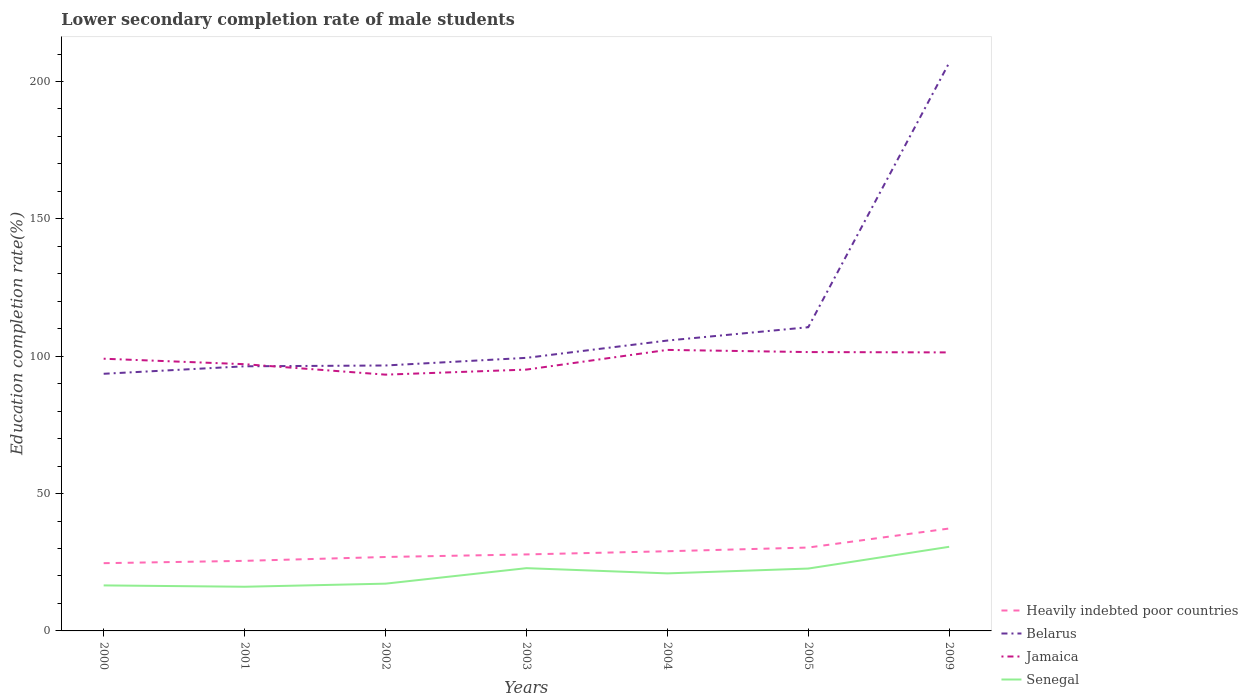How many different coloured lines are there?
Your response must be concise. 4. Does the line corresponding to Senegal intersect with the line corresponding to Belarus?
Make the answer very short. No. Across all years, what is the maximum lower secondary completion rate of male students in Jamaica?
Keep it short and to the point. 93.29. What is the total lower secondary completion rate of male students in Senegal in the graph?
Ensure brevity in your answer.  -3.74. What is the difference between the highest and the second highest lower secondary completion rate of male students in Jamaica?
Make the answer very short. 9.01. What is the difference between the highest and the lowest lower secondary completion rate of male students in Jamaica?
Offer a very short reply. 4. How many lines are there?
Your response must be concise. 4. Are the values on the major ticks of Y-axis written in scientific E-notation?
Provide a short and direct response. No. Does the graph contain any zero values?
Offer a very short reply. No. Does the graph contain grids?
Your answer should be very brief. No. How many legend labels are there?
Offer a terse response. 4. How are the legend labels stacked?
Provide a short and direct response. Vertical. What is the title of the graph?
Your response must be concise. Lower secondary completion rate of male students. Does "Ethiopia" appear as one of the legend labels in the graph?
Your answer should be very brief. No. What is the label or title of the Y-axis?
Your response must be concise. Education completion rate(%). What is the Education completion rate(%) in Heavily indebted poor countries in 2000?
Offer a terse response. 24.66. What is the Education completion rate(%) of Belarus in 2000?
Your response must be concise. 93.61. What is the Education completion rate(%) of Jamaica in 2000?
Give a very brief answer. 99.09. What is the Education completion rate(%) in Senegal in 2000?
Keep it short and to the point. 16.57. What is the Education completion rate(%) in Heavily indebted poor countries in 2001?
Offer a very short reply. 25.51. What is the Education completion rate(%) in Belarus in 2001?
Your answer should be compact. 96.33. What is the Education completion rate(%) of Jamaica in 2001?
Keep it short and to the point. 97.1. What is the Education completion rate(%) of Senegal in 2001?
Provide a short and direct response. 16.08. What is the Education completion rate(%) in Heavily indebted poor countries in 2002?
Your response must be concise. 26.91. What is the Education completion rate(%) in Belarus in 2002?
Provide a succinct answer. 96.63. What is the Education completion rate(%) in Jamaica in 2002?
Offer a terse response. 93.29. What is the Education completion rate(%) in Senegal in 2002?
Your answer should be very brief. 17.2. What is the Education completion rate(%) of Heavily indebted poor countries in 2003?
Provide a short and direct response. 27.85. What is the Education completion rate(%) of Belarus in 2003?
Provide a short and direct response. 99.41. What is the Education completion rate(%) of Jamaica in 2003?
Provide a short and direct response. 95.13. What is the Education completion rate(%) in Senegal in 2003?
Offer a terse response. 22.85. What is the Education completion rate(%) in Heavily indebted poor countries in 2004?
Ensure brevity in your answer.  29. What is the Education completion rate(%) in Belarus in 2004?
Give a very brief answer. 105.7. What is the Education completion rate(%) of Jamaica in 2004?
Ensure brevity in your answer.  102.3. What is the Education completion rate(%) in Senegal in 2004?
Your answer should be compact. 20.95. What is the Education completion rate(%) of Heavily indebted poor countries in 2005?
Offer a very short reply. 30.36. What is the Education completion rate(%) in Belarus in 2005?
Offer a terse response. 110.55. What is the Education completion rate(%) in Jamaica in 2005?
Offer a terse response. 101.51. What is the Education completion rate(%) in Senegal in 2005?
Ensure brevity in your answer.  22.7. What is the Education completion rate(%) in Heavily indebted poor countries in 2009?
Keep it short and to the point. 37.29. What is the Education completion rate(%) in Belarus in 2009?
Ensure brevity in your answer.  206.82. What is the Education completion rate(%) of Jamaica in 2009?
Your response must be concise. 101.39. What is the Education completion rate(%) of Senegal in 2009?
Your answer should be very brief. 30.62. Across all years, what is the maximum Education completion rate(%) of Heavily indebted poor countries?
Your response must be concise. 37.29. Across all years, what is the maximum Education completion rate(%) of Belarus?
Keep it short and to the point. 206.82. Across all years, what is the maximum Education completion rate(%) in Jamaica?
Your answer should be very brief. 102.3. Across all years, what is the maximum Education completion rate(%) in Senegal?
Ensure brevity in your answer.  30.62. Across all years, what is the minimum Education completion rate(%) of Heavily indebted poor countries?
Offer a terse response. 24.66. Across all years, what is the minimum Education completion rate(%) of Belarus?
Your answer should be very brief. 93.61. Across all years, what is the minimum Education completion rate(%) of Jamaica?
Your response must be concise. 93.29. Across all years, what is the minimum Education completion rate(%) in Senegal?
Your response must be concise. 16.08. What is the total Education completion rate(%) of Heavily indebted poor countries in the graph?
Offer a very short reply. 201.58. What is the total Education completion rate(%) of Belarus in the graph?
Offer a terse response. 809.05. What is the total Education completion rate(%) in Jamaica in the graph?
Your answer should be compact. 689.82. What is the total Education completion rate(%) in Senegal in the graph?
Your response must be concise. 146.97. What is the difference between the Education completion rate(%) of Heavily indebted poor countries in 2000 and that in 2001?
Offer a very short reply. -0.85. What is the difference between the Education completion rate(%) in Belarus in 2000 and that in 2001?
Offer a very short reply. -2.72. What is the difference between the Education completion rate(%) in Jamaica in 2000 and that in 2001?
Your answer should be very brief. 1.99. What is the difference between the Education completion rate(%) of Senegal in 2000 and that in 2001?
Give a very brief answer. 0.49. What is the difference between the Education completion rate(%) in Heavily indebted poor countries in 2000 and that in 2002?
Ensure brevity in your answer.  -2.25. What is the difference between the Education completion rate(%) in Belarus in 2000 and that in 2002?
Your response must be concise. -3.02. What is the difference between the Education completion rate(%) in Jamaica in 2000 and that in 2002?
Your response must be concise. 5.8. What is the difference between the Education completion rate(%) of Senegal in 2000 and that in 2002?
Make the answer very short. -0.64. What is the difference between the Education completion rate(%) of Heavily indebted poor countries in 2000 and that in 2003?
Give a very brief answer. -3.19. What is the difference between the Education completion rate(%) in Belarus in 2000 and that in 2003?
Make the answer very short. -5.8. What is the difference between the Education completion rate(%) in Jamaica in 2000 and that in 2003?
Your response must be concise. 3.96. What is the difference between the Education completion rate(%) of Senegal in 2000 and that in 2003?
Make the answer very short. -6.28. What is the difference between the Education completion rate(%) in Heavily indebted poor countries in 2000 and that in 2004?
Make the answer very short. -4.34. What is the difference between the Education completion rate(%) of Belarus in 2000 and that in 2004?
Your answer should be compact. -12.1. What is the difference between the Education completion rate(%) in Jamaica in 2000 and that in 2004?
Ensure brevity in your answer.  -3.21. What is the difference between the Education completion rate(%) in Senegal in 2000 and that in 2004?
Your answer should be very brief. -4.38. What is the difference between the Education completion rate(%) in Heavily indebted poor countries in 2000 and that in 2005?
Offer a very short reply. -5.7. What is the difference between the Education completion rate(%) in Belarus in 2000 and that in 2005?
Give a very brief answer. -16.95. What is the difference between the Education completion rate(%) in Jamaica in 2000 and that in 2005?
Make the answer very short. -2.42. What is the difference between the Education completion rate(%) in Senegal in 2000 and that in 2005?
Offer a very short reply. -6.14. What is the difference between the Education completion rate(%) in Heavily indebted poor countries in 2000 and that in 2009?
Make the answer very short. -12.62. What is the difference between the Education completion rate(%) of Belarus in 2000 and that in 2009?
Your answer should be compact. -113.22. What is the difference between the Education completion rate(%) of Jamaica in 2000 and that in 2009?
Ensure brevity in your answer.  -2.3. What is the difference between the Education completion rate(%) of Senegal in 2000 and that in 2009?
Your response must be concise. -14.06. What is the difference between the Education completion rate(%) of Heavily indebted poor countries in 2001 and that in 2002?
Offer a terse response. -1.4. What is the difference between the Education completion rate(%) in Belarus in 2001 and that in 2002?
Ensure brevity in your answer.  -0.3. What is the difference between the Education completion rate(%) in Jamaica in 2001 and that in 2002?
Your answer should be compact. 3.81. What is the difference between the Education completion rate(%) of Senegal in 2001 and that in 2002?
Provide a succinct answer. -1.12. What is the difference between the Education completion rate(%) of Heavily indebted poor countries in 2001 and that in 2003?
Your response must be concise. -2.34. What is the difference between the Education completion rate(%) of Belarus in 2001 and that in 2003?
Your answer should be very brief. -3.08. What is the difference between the Education completion rate(%) in Jamaica in 2001 and that in 2003?
Provide a succinct answer. 1.97. What is the difference between the Education completion rate(%) in Senegal in 2001 and that in 2003?
Make the answer very short. -6.77. What is the difference between the Education completion rate(%) of Heavily indebted poor countries in 2001 and that in 2004?
Provide a short and direct response. -3.49. What is the difference between the Education completion rate(%) of Belarus in 2001 and that in 2004?
Offer a very short reply. -9.37. What is the difference between the Education completion rate(%) of Jamaica in 2001 and that in 2004?
Your response must be concise. -5.2. What is the difference between the Education completion rate(%) in Senegal in 2001 and that in 2004?
Provide a succinct answer. -4.87. What is the difference between the Education completion rate(%) of Heavily indebted poor countries in 2001 and that in 2005?
Offer a terse response. -4.85. What is the difference between the Education completion rate(%) in Belarus in 2001 and that in 2005?
Provide a short and direct response. -14.22. What is the difference between the Education completion rate(%) of Jamaica in 2001 and that in 2005?
Offer a very short reply. -4.41. What is the difference between the Education completion rate(%) of Senegal in 2001 and that in 2005?
Your answer should be very brief. -6.62. What is the difference between the Education completion rate(%) in Heavily indebted poor countries in 2001 and that in 2009?
Give a very brief answer. -11.78. What is the difference between the Education completion rate(%) of Belarus in 2001 and that in 2009?
Offer a terse response. -110.49. What is the difference between the Education completion rate(%) of Jamaica in 2001 and that in 2009?
Keep it short and to the point. -4.29. What is the difference between the Education completion rate(%) of Senegal in 2001 and that in 2009?
Offer a very short reply. -14.54. What is the difference between the Education completion rate(%) of Heavily indebted poor countries in 2002 and that in 2003?
Keep it short and to the point. -0.94. What is the difference between the Education completion rate(%) in Belarus in 2002 and that in 2003?
Your answer should be compact. -2.78. What is the difference between the Education completion rate(%) in Jamaica in 2002 and that in 2003?
Keep it short and to the point. -1.84. What is the difference between the Education completion rate(%) of Senegal in 2002 and that in 2003?
Your response must be concise. -5.64. What is the difference between the Education completion rate(%) in Heavily indebted poor countries in 2002 and that in 2004?
Give a very brief answer. -2.09. What is the difference between the Education completion rate(%) of Belarus in 2002 and that in 2004?
Offer a terse response. -9.08. What is the difference between the Education completion rate(%) of Jamaica in 2002 and that in 2004?
Ensure brevity in your answer.  -9.01. What is the difference between the Education completion rate(%) of Senegal in 2002 and that in 2004?
Keep it short and to the point. -3.74. What is the difference between the Education completion rate(%) in Heavily indebted poor countries in 2002 and that in 2005?
Your response must be concise. -3.44. What is the difference between the Education completion rate(%) of Belarus in 2002 and that in 2005?
Provide a short and direct response. -13.93. What is the difference between the Education completion rate(%) in Jamaica in 2002 and that in 2005?
Your response must be concise. -8.22. What is the difference between the Education completion rate(%) in Senegal in 2002 and that in 2005?
Give a very brief answer. -5.5. What is the difference between the Education completion rate(%) of Heavily indebted poor countries in 2002 and that in 2009?
Your answer should be compact. -10.37. What is the difference between the Education completion rate(%) of Belarus in 2002 and that in 2009?
Your answer should be compact. -110.2. What is the difference between the Education completion rate(%) of Jamaica in 2002 and that in 2009?
Keep it short and to the point. -8.09. What is the difference between the Education completion rate(%) of Senegal in 2002 and that in 2009?
Make the answer very short. -13.42. What is the difference between the Education completion rate(%) of Heavily indebted poor countries in 2003 and that in 2004?
Your response must be concise. -1.16. What is the difference between the Education completion rate(%) of Belarus in 2003 and that in 2004?
Make the answer very short. -6.3. What is the difference between the Education completion rate(%) of Jamaica in 2003 and that in 2004?
Keep it short and to the point. -7.17. What is the difference between the Education completion rate(%) in Senegal in 2003 and that in 2004?
Provide a succinct answer. 1.9. What is the difference between the Education completion rate(%) of Heavily indebted poor countries in 2003 and that in 2005?
Give a very brief answer. -2.51. What is the difference between the Education completion rate(%) of Belarus in 2003 and that in 2005?
Offer a terse response. -11.14. What is the difference between the Education completion rate(%) of Jamaica in 2003 and that in 2005?
Ensure brevity in your answer.  -6.38. What is the difference between the Education completion rate(%) of Senegal in 2003 and that in 2005?
Your answer should be compact. 0.14. What is the difference between the Education completion rate(%) of Heavily indebted poor countries in 2003 and that in 2009?
Offer a very short reply. -9.44. What is the difference between the Education completion rate(%) in Belarus in 2003 and that in 2009?
Offer a very short reply. -107.42. What is the difference between the Education completion rate(%) of Jamaica in 2003 and that in 2009?
Provide a succinct answer. -6.26. What is the difference between the Education completion rate(%) in Senegal in 2003 and that in 2009?
Your response must be concise. -7.78. What is the difference between the Education completion rate(%) in Heavily indebted poor countries in 2004 and that in 2005?
Provide a succinct answer. -1.35. What is the difference between the Education completion rate(%) in Belarus in 2004 and that in 2005?
Provide a succinct answer. -4.85. What is the difference between the Education completion rate(%) of Jamaica in 2004 and that in 2005?
Make the answer very short. 0.79. What is the difference between the Education completion rate(%) of Senegal in 2004 and that in 2005?
Offer a terse response. -1.76. What is the difference between the Education completion rate(%) in Heavily indebted poor countries in 2004 and that in 2009?
Provide a succinct answer. -8.28. What is the difference between the Education completion rate(%) of Belarus in 2004 and that in 2009?
Your answer should be compact. -101.12. What is the difference between the Education completion rate(%) in Jamaica in 2004 and that in 2009?
Give a very brief answer. 0.91. What is the difference between the Education completion rate(%) in Senegal in 2004 and that in 2009?
Offer a very short reply. -9.68. What is the difference between the Education completion rate(%) in Heavily indebted poor countries in 2005 and that in 2009?
Your response must be concise. -6.93. What is the difference between the Education completion rate(%) in Belarus in 2005 and that in 2009?
Provide a succinct answer. -96.27. What is the difference between the Education completion rate(%) of Jamaica in 2005 and that in 2009?
Make the answer very short. 0.12. What is the difference between the Education completion rate(%) of Senegal in 2005 and that in 2009?
Provide a succinct answer. -7.92. What is the difference between the Education completion rate(%) in Heavily indebted poor countries in 2000 and the Education completion rate(%) in Belarus in 2001?
Provide a short and direct response. -71.67. What is the difference between the Education completion rate(%) in Heavily indebted poor countries in 2000 and the Education completion rate(%) in Jamaica in 2001?
Offer a very short reply. -72.44. What is the difference between the Education completion rate(%) in Heavily indebted poor countries in 2000 and the Education completion rate(%) in Senegal in 2001?
Keep it short and to the point. 8.58. What is the difference between the Education completion rate(%) in Belarus in 2000 and the Education completion rate(%) in Jamaica in 2001?
Your answer should be compact. -3.49. What is the difference between the Education completion rate(%) of Belarus in 2000 and the Education completion rate(%) of Senegal in 2001?
Offer a terse response. 77.53. What is the difference between the Education completion rate(%) in Jamaica in 2000 and the Education completion rate(%) in Senegal in 2001?
Provide a succinct answer. 83.01. What is the difference between the Education completion rate(%) in Heavily indebted poor countries in 2000 and the Education completion rate(%) in Belarus in 2002?
Offer a very short reply. -71.97. What is the difference between the Education completion rate(%) of Heavily indebted poor countries in 2000 and the Education completion rate(%) of Jamaica in 2002?
Give a very brief answer. -68.63. What is the difference between the Education completion rate(%) in Heavily indebted poor countries in 2000 and the Education completion rate(%) in Senegal in 2002?
Ensure brevity in your answer.  7.46. What is the difference between the Education completion rate(%) of Belarus in 2000 and the Education completion rate(%) of Jamaica in 2002?
Your response must be concise. 0.31. What is the difference between the Education completion rate(%) in Belarus in 2000 and the Education completion rate(%) in Senegal in 2002?
Provide a short and direct response. 76.4. What is the difference between the Education completion rate(%) of Jamaica in 2000 and the Education completion rate(%) of Senegal in 2002?
Keep it short and to the point. 81.89. What is the difference between the Education completion rate(%) in Heavily indebted poor countries in 2000 and the Education completion rate(%) in Belarus in 2003?
Offer a very short reply. -74.75. What is the difference between the Education completion rate(%) of Heavily indebted poor countries in 2000 and the Education completion rate(%) of Jamaica in 2003?
Offer a very short reply. -70.47. What is the difference between the Education completion rate(%) in Heavily indebted poor countries in 2000 and the Education completion rate(%) in Senegal in 2003?
Make the answer very short. 1.81. What is the difference between the Education completion rate(%) in Belarus in 2000 and the Education completion rate(%) in Jamaica in 2003?
Your response must be concise. -1.53. What is the difference between the Education completion rate(%) in Belarus in 2000 and the Education completion rate(%) in Senegal in 2003?
Your response must be concise. 70.76. What is the difference between the Education completion rate(%) in Jamaica in 2000 and the Education completion rate(%) in Senegal in 2003?
Offer a terse response. 76.24. What is the difference between the Education completion rate(%) of Heavily indebted poor countries in 2000 and the Education completion rate(%) of Belarus in 2004?
Make the answer very short. -81.04. What is the difference between the Education completion rate(%) in Heavily indebted poor countries in 2000 and the Education completion rate(%) in Jamaica in 2004?
Provide a short and direct response. -77.64. What is the difference between the Education completion rate(%) of Heavily indebted poor countries in 2000 and the Education completion rate(%) of Senegal in 2004?
Keep it short and to the point. 3.71. What is the difference between the Education completion rate(%) in Belarus in 2000 and the Education completion rate(%) in Jamaica in 2004?
Provide a short and direct response. -8.69. What is the difference between the Education completion rate(%) of Belarus in 2000 and the Education completion rate(%) of Senegal in 2004?
Keep it short and to the point. 72.66. What is the difference between the Education completion rate(%) in Jamaica in 2000 and the Education completion rate(%) in Senegal in 2004?
Your answer should be very brief. 78.14. What is the difference between the Education completion rate(%) in Heavily indebted poor countries in 2000 and the Education completion rate(%) in Belarus in 2005?
Give a very brief answer. -85.89. What is the difference between the Education completion rate(%) in Heavily indebted poor countries in 2000 and the Education completion rate(%) in Jamaica in 2005?
Make the answer very short. -76.85. What is the difference between the Education completion rate(%) of Heavily indebted poor countries in 2000 and the Education completion rate(%) of Senegal in 2005?
Your answer should be compact. 1.96. What is the difference between the Education completion rate(%) in Belarus in 2000 and the Education completion rate(%) in Jamaica in 2005?
Provide a short and direct response. -7.9. What is the difference between the Education completion rate(%) of Belarus in 2000 and the Education completion rate(%) of Senegal in 2005?
Your response must be concise. 70.9. What is the difference between the Education completion rate(%) of Jamaica in 2000 and the Education completion rate(%) of Senegal in 2005?
Offer a very short reply. 76.39. What is the difference between the Education completion rate(%) in Heavily indebted poor countries in 2000 and the Education completion rate(%) in Belarus in 2009?
Offer a very short reply. -182.16. What is the difference between the Education completion rate(%) in Heavily indebted poor countries in 2000 and the Education completion rate(%) in Jamaica in 2009?
Keep it short and to the point. -76.73. What is the difference between the Education completion rate(%) in Heavily indebted poor countries in 2000 and the Education completion rate(%) in Senegal in 2009?
Give a very brief answer. -5.96. What is the difference between the Education completion rate(%) in Belarus in 2000 and the Education completion rate(%) in Jamaica in 2009?
Provide a succinct answer. -7.78. What is the difference between the Education completion rate(%) in Belarus in 2000 and the Education completion rate(%) in Senegal in 2009?
Provide a short and direct response. 62.98. What is the difference between the Education completion rate(%) in Jamaica in 2000 and the Education completion rate(%) in Senegal in 2009?
Ensure brevity in your answer.  68.47. What is the difference between the Education completion rate(%) in Heavily indebted poor countries in 2001 and the Education completion rate(%) in Belarus in 2002?
Offer a terse response. -71.12. What is the difference between the Education completion rate(%) of Heavily indebted poor countries in 2001 and the Education completion rate(%) of Jamaica in 2002?
Provide a short and direct response. -67.78. What is the difference between the Education completion rate(%) of Heavily indebted poor countries in 2001 and the Education completion rate(%) of Senegal in 2002?
Your answer should be very brief. 8.31. What is the difference between the Education completion rate(%) in Belarus in 2001 and the Education completion rate(%) in Jamaica in 2002?
Offer a terse response. 3.04. What is the difference between the Education completion rate(%) of Belarus in 2001 and the Education completion rate(%) of Senegal in 2002?
Make the answer very short. 79.13. What is the difference between the Education completion rate(%) of Jamaica in 2001 and the Education completion rate(%) of Senegal in 2002?
Provide a succinct answer. 79.9. What is the difference between the Education completion rate(%) of Heavily indebted poor countries in 2001 and the Education completion rate(%) of Belarus in 2003?
Provide a short and direct response. -73.9. What is the difference between the Education completion rate(%) of Heavily indebted poor countries in 2001 and the Education completion rate(%) of Jamaica in 2003?
Keep it short and to the point. -69.62. What is the difference between the Education completion rate(%) in Heavily indebted poor countries in 2001 and the Education completion rate(%) in Senegal in 2003?
Your answer should be compact. 2.66. What is the difference between the Education completion rate(%) of Belarus in 2001 and the Education completion rate(%) of Jamaica in 2003?
Offer a terse response. 1.2. What is the difference between the Education completion rate(%) of Belarus in 2001 and the Education completion rate(%) of Senegal in 2003?
Offer a terse response. 73.48. What is the difference between the Education completion rate(%) of Jamaica in 2001 and the Education completion rate(%) of Senegal in 2003?
Offer a terse response. 74.25. What is the difference between the Education completion rate(%) of Heavily indebted poor countries in 2001 and the Education completion rate(%) of Belarus in 2004?
Give a very brief answer. -80.19. What is the difference between the Education completion rate(%) of Heavily indebted poor countries in 2001 and the Education completion rate(%) of Jamaica in 2004?
Ensure brevity in your answer.  -76.79. What is the difference between the Education completion rate(%) of Heavily indebted poor countries in 2001 and the Education completion rate(%) of Senegal in 2004?
Give a very brief answer. 4.56. What is the difference between the Education completion rate(%) in Belarus in 2001 and the Education completion rate(%) in Jamaica in 2004?
Offer a terse response. -5.97. What is the difference between the Education completion rate(%) of Belarus in 2001 and the Education completion rate(%) of Senegal in 2004?
Give a very brief answer. 75.38. What is the difference between the Education completion rate(%) in Jamaica in 2001 and the Education completion rate(%) in Senegal in 2004?
Make the answer very short. 76.15. What is the difference between the Education completion rate(%) of Heavily indebted poor countries in 2001 and the Education completion rate(%) of Belarus in 2005?
Offer a very short reply. -85.04. What is the difference between the Education completion rate(%) of Heavily indebted poor countries in 2001 and the Education completion rate(%) of Jamaica in 2005?
Provide a succinct answer. -76. What is the difference between the Education completion rate(%) in Heavily indebted poor countries in 2001 and the Education completion rate(%) in Senegal in 2005?
Your answer should be compact. 2.81. What is the difference between the Education completion rate(%) in Belarus in 2001 and the Education completion rate(%) in Jamaica in 2005?
Your answer should be very brief. -5.18. What is the difference between the Education completion rate(%) in Belarus in 2001 and the Education completion rate(%) in Senegal in 2005?
Keep it short and to the point. 73.63. What is the difference between the Education completion rate(%) of Jamaica in 2001 and the Education completion rate(%) of Senegal in 2005?
Your answer should be compact. 74.4. What is the difference between the Education completion rate(%) in Heavily indebted poor countries in 2001 and the Education completion rate(%) in Belarus in 2009?
Provide a succinct answer. -181.31. What is the difference between the Education completion rate(%) in Heavily indebted poor countries in 2001 and the Education completion rate(%) in Jamaica in 2009?
Your answer should be compact. -75.88. What is the difference between the Education completion rate(%) of Heavily indebted poor countries in 2001 and the Education completion rate(%) of Senegal in 2009?
Give a very brief answer. -5.11. What is the difference between the Education completion rate(%) in Belarus in 2001 and the Education completion rate(%) in Jamaica in 2009?
Provide a short and direct response. -5.06. What is the difference between the Education completion rate(%) of Belarus in 2001 and the Education completion rate(%) of Senegal in 2009?
Keep it short and to the point. 65.71. What is the difference between the Education completion rate(%) of Jamaica in 2001 and the Education completion rate(%) of Senegal in 2009?
Provide a short and direct response. 66.48. What is the difference between the Education completion rate(%) of Heavily indebted poor countries in 2002 and the Education completion rate(%) of Belarus in 2003?
Make the answer very short. -72.5. What is the difference between the Education completion rate(%) in Heavily indebted poor countries in 2002 and the Education completion rate(%) in Jamaica in 2003?
Give a very brief answer. -68.22. What is the difference between the Education completion rate(%) of Heavily indebted poor countries in 2002 and the Education completion rate(%) of Senegal in 2003?
Make the answer very short. 4.07. What is the difference between the Education completion rate(%) of Belarus in 2002 and the Education completion rate(%) of Jamaica in 2003?
Make the answer very short. 1.49. What is the difference between the Education completion rate(%) of Belarus in 2002 and the Education completion rate(%) of Senegal in 2003?
Provide a succinct answer. 73.78. What is the difference between the Education completion rate(%) in Jamaica in 2002 and the Education completion rate(%) in Senegal in 2003?
Keep it short and to the point. 70.45. What is the difference between the Education completion rate(%) of Heavily indebted poor countries in 2002 and the Education completion rate(%) of Belarus in 2004?
Offer a very short reply. -78.79. What is the difference between the Education completion rate(%) in Heavily indebted poor countries in 2002 and the Education completion rate(%) in Jamaica in 2004?
Provide a short and direct response. -75.39. What is the difference between the Education completion rate(%) in Heavily indebted poor countries in 2002 and the Education completion rate(%) in Senegal in 2004?
Your answer should be very brief. 5.97. What is the difference between the Education completion rate(%) in Belarus in 2002 and the Education completion rate(%) in Jamaica in 2004?
Provide a short and direct response. -5.67. What is the difference between the Education completion rate(%) of Belarus in 2002 and the Education completion rate(%) of Senegal in 2004?
Your answer should be compact. 75.68. What is the difference between the Education completion rate(%) of Jamaica in 2002 and the Education completion rate(%) of Senegal in 2004?
Give a very brief answer. 72.35. What is the difference between the Education completion rate(%) of Heavily indebted poor countries in 2002 and the Education completion rate(%) of Belarus in 2005?
Provide a short and direct response. -83.64. What is the difference between the Education completion rate(%) in Heavily indebted poor countries in 2002 and the Education completion rate(%) in Jamaica in 2005?
Provide a short and direct response. -74.6. What is the difference between the Education completion rate(%) of Heavily indebted poor countries in 2002 and the Education completion rate(%) of Senegal in 2005?
Offer a very short reply. 4.21. What is the difference between the Education completion rate(%) in Belarus in 2002 and the Education completion rate(%) in Jamaica in 2005?
Your response must be concise. -4.88. What is the difference between the Education completion rate(%) of Belarus in 2002 and the Education completion rate(%) of Senegal in 2005?
Offer a very short reply. 73.92. What is the difference between the Education completion rate(%) of Jamaica in 2002 and the Education completion rate(%) of Senegal in 2005?
Provide a succinct answer. 70.59. What is the difference between the Education completion rate(%) of Heavily indebted poor countries in 2002 and the Education completion rate(%) of Belarus in 2009?
Ensure brevity in your answer.  -179.91. What is the difference between the Education completion rate(%) of Heavily indebted poor countries in 2002 and the Education completion rate(%) of Jamaica in 2009?
Keep it short and to the point. -74.48. What is the difference between the Education completion rate(%) of Heavily indebted poor countries in 2002 and the Education completion rate(%) of Senegal in 2009?
Offer a very short reply. -3.71. What is the difference between the Education completion rate(%) of Belarus in 2002 and the Education completion rate(%) of Jamaica in 2009?
Offer a terse response. -4.76. What is the difference between the Education completion rate(%) of Belarus in 2002 and the Education completion rate(%) of Senegal in 2009?
Provide a succinct answer. 66. What is the difference between the Education completion rate(%) of Jamaica in 2002 and the Education completion rate(%) of Senegal in 2009?
Provide a short and direct response. 62.67. What is the difference between the Education completion rate(%) of Heavily indebted poor countries in 2003 and the Education completion rate(%) of Belarus in 2004?
Keep it short and to the point. -77.86. What is the difference between the Education completion rate(%) of Heavily indebted poor countries in 2003 and the Education completion rate(%) of Jamaica in 2004?
Your response must be concise. -74.45. What is the difference between the Education completion rate(%) in Heavily indebted poor countries in 2003 and the Education completion rate(%) in Senegal in 2004?
Your response must be concise. 6.9. What is the difference between the Education completion rate(%) in Belarus in 2003 and the Education completion rate(%) in Jamaica in 2004?
Offer a very short reply. -2.89. What is the difference between the Education completion rate(%) in Belarus in 2003 and the Education completion rate(%) in Senegal in 2004?
Your answer should be compact. 78.46. What is the difference between the Education completion rate(%) in Jamaica in 2003 and the Education completion rate(%) in Senegal in 2004?
Ensure brevity in your answer.  74.19. What is the difference between the Education completion rate(%) of Heavily indebted poor countries in 2003 and the Education completion rate(%) of Belarus in 2005?
Make the answer very short. -82.71. What is the difference between the Education completion rate(%) in Heavily indebted poor countries in 2003 and the Education completion rate(%) in Jamaica in 2005?
Offer a terse response. -73.66. What is the difference between the Education completion rate(%) in Heavily indebted poor countries in 2003 and the Education completion rate(%) in Senegal in 2005?
Provide a succinct answer. 5.14. What is the difference between the Education completion rate(%) of Belarus in 2003 and the Education completion rate(%) of Jamaica in 2005?
Provide a short and direct response. -2.1. What is the difference between the Education completion rate(%) in Belarus in 2003 and the Education completion rate(%) in Senegal in 2005?
Your answer should be very brief. 76.7. What is the difference between the Education completion rate(%) of Jamaica in 2003 and the Education completion rate(%) of Senegal in 2005?
Your answer should be very brief. 72.43. What is the difference between the Education completion rate(%) in Heavily indebted poor countries in 2003 and the Education completion rate(%) in Belarus in 2009?
Your answer should be very brief. -178.98. What is the difference between the Education completion rate(%) in Heavily indebted poor countries in 2003 and the Education completion rate(%) in Jamaica in 2009?
Provide a succinct answer. -73.54. What is the difference between the Education completion rate(%) of Heavily indebted poor countries in 2003 and the Education completion rate(%) of Senegal in 2009?
Keep it short and to the point. -2.78. What is the difference between the Education completion rate(%) in Belarus in 2003 and the Education completion rate(%) in Jamaica in 2009?
Give a very brief answer. -1.98. What is the difference between the Education completion rate(%) of Belarus in 2003 and the Education completion rate(%) of Senegal in 2009?
Your response must be concise. 68.79. What is the difference between the Education completion rate(%) in Jamaica in 2003 and the Education completion rate(%) in Senegal in 2009?
Your answer should be very brief. 64.51. What is the difference between the Education completion rate(%) in Heavily indebted poor countries in 2004 and the Education completion rate(%) in Belarus in 2005?
Ensure brevity in your answer.  -81.55. What is the difference between the Education completion rate(%) of Heavily indebted poor countries in 2004 and the Education completion rate(%) of Jamaica in 2005?
Your response must be concise. -72.51. What is the difference between the Education completion rate(%) of Heavily indebted poor countries in 2004 and the Education completion rate(%) of Senegal in 2005?
Your response must be concise. 6.3. What is the difference between the Education completion rate(%) of Belarus in 2004 and the Education completion rate(%) of Jamaica in 2005?
Ensure brevity in your answer.  4.19. What is the difference between the Education completion rate(%) of Belarus in 2004 and the Education completion rate(%) of Senegal in 2005?
Your answer should be compact. 83. What is the difference between the Education completion rate(%) in Jamaica in 2004 and the Education completion rate(%) in Senegal in 2005?
Offer a terse response. 79.6. What is the difference between the Education completion rate(%) of Heavily indebted poor countries in 2004 and the Education completion rate(%) of Belarus in 2009?
Your answer should be compact. -177.82. What is the difference between the Education completion rate(%) of Heavily indebted poor countries in 2004 and the Education completion rate(%) of Jamaica in 2009?
Give a very brief answer. -72.38. What is the difference between the Education completion rate(%) in Heavily indebted poor countries in 2004 and the Education completion rate(%) in Senegal in 2009?
Ensure brevity in your answer.  -1.62. What is the difference between the Education completion rate(%) in Belarus in 2004 and the Education completion rate(%) in Jamaica in 2009?
Ensure brevity in your answer.  4.32. What is the difference between the Education completion rate(%) in Belarus in 2004 and the Education completion rate(%) in Senegal in 2009?
Your answer should be very brief. 75.08. What is the difference between the Education completion rate(%) of Jamaica in 2004 and the Education completion rate(%) of Senegal in 2009?
Your answer should be very brief. 71.68. What is the difference between the Education completion rate(%) of Heavily indebted poor countries in 2005 and the Education completion rate(%) of Belarus in 2009?
Provide a short and direct response. -176.47. What is the difference between the Education completion rate(%) in Heavily indebted poor countries in 2005 and the Education completion rate(%) in Jamaica in 2009?
Make the answer very short. -71.03. What is the difference between the Education completion rate(%) of Heavily indebted poor countries in 2005 and the Education completion rate(%) of Senegal in 2009?
Give a very brief answer. -0.27. What is the difference between the Education completion rate(%) in Belarus in 2005 and the Education completion rate(%) in Jamaica in 2009?
Your answer should be very brief. 9.16. What is the difference between the Education completion rate(%) in Belarus in 2005 and the Education completion rate(%) in Senegal in 2009?
Give a very brief answer. 79.93. What is the difference between the Education completion rate(%) in Jamaica in 2005 and the Education completion rate(%) in Senegal in 2009?
Make the answer very short. 70.89. What is the average Education completion rate(%) in Heavily indebted poor countries per year?
Your response must be concise. 28.8. What is the average Education completion rate(%) of Belarus per year?
Your answer should be compact. 115.58. What is the average Education completion rate(%) of Jamaica per year?
Provide a succinct answer. 98.55. What is the average Education completion rate(%) of Senegal per year?
Make the answer very short. 21. In the year 2000, what is the difference between the Education completion rate(%) in Heavily indebted poor countries and Education completion rate(%) in Belarus?
Offer a very short reply. -68.95. In the year 2000, what is the difference between the Education completion rate(%) in Heavily indebted poor countries and Education completion rate(%) in Jamaica?
Your answer should be very brief. -74.43. In the year 2000, what is the difference between the Education completion rate(%) in Heavily indebted poor countries and Education completion rate(%) in Senegal?
Offer a terse response. 8.09. In the year 2000, what is the difference between the Education completion rate(%) of Belarus and Education completion rate(%) of Jamaica?
Offer a very short reply. -5.48. In the year 2000, what is the difference between the Education completion rate(%) of Belarus and Education completion rate(%) of Senegal?
Your answer should be very brief. 77.04. In the year 2000, what is the difference between the Education completion rate(%) in Jamaica and Education completion rate(%) in Senegal?
Provide a short and direct response. 82.52. In the year 2001, what is the difference between the Education completion rate(%) of Heavily indebted poor countries and Education completion rate(%) of Belarus?
Your answer should be compact. -70.82. In the year 2001, what is the difference between the Education completion rate(%) in Heavily indebted poor countries and Education completion rate(%) in Jamaica?
Your response must be concise. -71.59. In the year 2001, what is the difference between the Education completion rate(%) in Heavily indebted poor countries and Education completion rate(%) in Senegal?
Your response must be concise. 9.43. In the year 2001, what is the difference between the Education completion rate(%) in Belarus and Education completion rate(%) in Jamaica?
Give a very brief answer. -0.77. In the year 2001, what is the difference between the Education completion rate(%) of Belarus and Education completion rate(%) of Senegal?
Offer a very short reply. 80.25. In the year 2001, what is the difference between the Education completion rate(%) of Jamaica and Education completion rate(%) of Senegal?
Offer a terse response. 81.02. In the year 2002, what is the difference between the Education completion rate(%) in Heavily indebted poor countries and Education completion rate(%) in Belarus?
Ensure brevity in your answer.  -69.71. In the year 2002, what is the difference between the Education completion rate(%) of Heavily indebted poor countries and Education completion rate(%) of Jamaica?
Provide a succinct answer. -66.38. In the year 2002, what is the difference between the Education completion rate(%) in Heavily indebted poor countries and Education completion rate(%) in Senegal?
Give a very brief answer. 9.71. In the year 2002, what is the difference between the Education completion rate(%) in Belarus and Education completion rate(%) in Jamaica?
Offer a terse response. 3.33. In the year 2002, what is the difference between the Education completion rate(%) in Belarus and Education completion rate(%) in Senegal?
Offer a very short reply. 79.42. In the year 2002, what is the difference between the Education completion rate(%) in Jamaica and Education completion rate(%) in Senegal?
Offer a terse response. 76.09. In the year 2003, what is the difference between the Education completion rate(%) in Heavily indebted poor countries and Education completion rate(%) in Belarus?
Your answer should be very brief. -71.56. In the year 2003, what is the difference between the Education completion rate(%) of Heavily indebted poor countries and Education completion rate(%) of Jamaica?
Provide a succinct answer. -67.28. In the year 2003, what is the difference between the Education completion rate(%) of Heavily indebted poor countries and Education completion rate(%) of Senegal?
Ensure brevity in your answer.  5. In the year 2003, what is the difference between the Education completion rate(%) in Belarus and Education completion rate(%) in Jamaica?
Your answer should be compact. 4.28. In the year 2003, what is the difference between the Education completion rate(%) in Belarus and Education completion rate(%) in Senegal?
Make the answer very short. 76.56. In the year 2003, what is the difference between the Education completion rate(%) in Jamaica and Education completion rate(%) in Senegal?
Make the answer very short. 72.29. In the year 2004, what is the difference between the Education completion rate(%) of Heavily indebted poor countries and Education completion rate(%) of Belarus?
Offer a terse response. -76.7. In the year 2004, what is the difference between the Education completion rate(%) in Heavily indebted poor countries and Education completion rate(%) in Jamaica?
Offer a terse response. -73.3. In the year 2004, what is the difference between the Education completion rate(%) in Heavily indebted poor countries and Education completion rate(%) in Senegal?
Your answer should be very brief. 8.06. In the year 2004, what is the difference between the Education completion rate(%) in Belarus and Education completion rate(%) in Jamaica?
Make the answer very short. 3.4. In the year 2004, what is the difference between the Education completion rate(%) in Belarus and Education completion rate(%) in Senegal?
Your response must be concise. 84.76. In the year 2004, what is the difference between the Education completion rate(%) in Jamaica and Education completion rate(%) in Senegal?
Your response must be concise. 81.35. In the year 2005, what is the difference between the Education completion rate(%) in Heavily indebted poor countries and Education completion rate(%) in Belarus?
Ensure brevity in your answer.  -80.2. In the year 2005, what is the difference between the Education completion rate(%) of Heavily indebted poor countries and Education completion rate(%) of Jamaica?
Offer a very short reply. -71.15. In the year 2005, what is the difference between the Education completion rate(%) in Heavily indebted poor countries and Education completion rate(%) in Senegal?
Keep it short and to the point. 7.65. In the year 2005, what is the difference between the Education completion rate(%) of Belarus and Education completion rate(%) of Jamaica?
Give a very brief answer. 9.04. In the year 2005, what is the difference between the Education completion rate(%) of Belarus and Education completion rate(%) of Senegal?
Keep it short and to the point. 87.85. In the year 2005, what is the difference between the Education completion rate(%) of Jamaica and Education completion rate(%) of Senegal?
Your answer should be very brief. 78.81. In the year 2009, what is the difference between the Education completion rate(%) of Heavily indebted poor countries and Education completion rate(%) of Belarus?
Offer a terse response. -169.54. In the year 2009, what is the difference between the Education completion rate(%) of Heavily indebted poor countries and Education completion rate(%) of Jamaica?
Offer a terse response. -64.1. In the year 2009, what is the difference between the Education completion rate(%) in Heavily indebted poor countries and Education completion rate(%) in Senegal?
Offer a terse response. 6.66. In the year 2009, what is the difference between the Education completion rate(%) in Belarus and Education completion rate(%) in Jamaica?
Your answer should be compact. 105.44. In the year 2009, what is the difference between the Education completion rate(%) of Belarus and Education completion rate(%) of Senegal?
Your answer should be compact. 176.2. In the year 2009, what is the difference between the Education completion rate(%) in Jamaica and Education completion rate(%) in Senegal?
Keep it short and to the point. 70.77. What is the ratio of the Education completion rate(%) of Heavily indebted poor countries in 2000 to that in 2001?
Ensure brevity in your answer.  0.97. What is the ratio of the Education completion rate(%) in Belarus in 2000 to that in 2001?
Keep it short and to the point. 0.97. What is the ratio of the Education completion rate(%) in Jamaica in 2000 to that in 2001?
Your answer should be very brief. 1.02. What is the ratio of the Education completion rate(%) in Senegal in 2000 to that in 2001?
Your response must be concise. 1.03. What is the ratio of the Education completion rate(%) of Heavily indebted poor countries in 2000 to that in 2002?
Give a very brief answer. 0.92. What is the ratio of the Education completion rate(%) of Belarus in 2000 to that in 2002?
Your response must be concise. 0.97. What is the ratio of the Education completion rate(%) in Jamaica in 2000 to that in 2002?
Offer a very short reply. 1.06. What is the ratio of the Education completion rate(%) in Senegal in 2000 to that in 2002?
Your answer should be compact. 0.96. What is the ratio of the Education completion rate(%) in Heavily indebted poor countries in 2000 to that in 2003?
Your answer should be very brief. 0.89. What is the ratio of the Education completion rate(%) of Belarus in 2000 to that in 2003?
Your response must be concise. 0.94. What is the ratio of the Education completion rate(%) of Jamaica in 2000 to that in 2003?
Offer a terse response. 1.04. What is the ratio of the Education completion rate(%) of Senegal in 2000 to that in 2003?
Your answer should be compact. 0.73. What is the ratio of the Education completion rate(%) of Heavily indebted poor countries in 2000 to that in 2004?
Offer a very short reply. 0.85. What is the ratio of the Education completion rate(%) in Belarus in 2000 to that in 2004?
Keep it short and to the point. 0.89. What is the ratio of the Education completion rate(%) of Jamaica in 2000 to that in 2004?
Provide a short and direct response. 0.97. What is the ratio of the Education completion rate(%) of Senegal in 2000 to that in 2004?
Make the answer very short. 0.79. What is the ratio of the Education completion rate(%) of Heavily indebted poor countries in 2000 to that in 2005?
Provide a succinct answer. 0.81. What is the ratio of the Education completion rate(%) in Belarus in 2000 to that in 2005?
Provide a succinct answer. 0.85. What is the ratio of the Education completion rate(%) in Jamaica in 2000 to that in 2005?
Make the answer very short. 0.98. What is the ratio of the Education completion rate(%) in Senegal in 2000 to that in 2005?
Offer a very short reply. 0.73. What is the ratio of the Education completion rate(%) in Heavily indebted poor countries in 2000 to that in 2009?
Ensure brevity in your answer.  0.66. What is the ratio of the Education completion rate(%) of Belarus in 2000 to that in 2009?
Provide a short and direct response. 0.45. What is the ratio of the Education completion rate(%) of Jamaica in 2000 to that in 2009?
Provide a short and direct response. 0.98. What is the ratio of the Education completion rate(%) in Senegal in 2000 to that in 2009?
Make the answer very short. 0.54. What is the ratio of the Education completion rate(%) of Heavily indebted poor countries in 2001 to that in 2002?
Your answer should be very brief. 0.95. What is the ratio of the Education completion rate(%) in Jamaica in 2001 to that in 2002?
Offer a very short reply. 1.04. What is the ratio of the Education completion rate(%) of Senegal in 2001 to that in 2002?
Ensure brevity in your answer.  0.93. What is the ratio of the Education completion rate(%) in Heavily indebted poor countries in 2001 to that in 2003?
Ensure brevity in your answer.  0.92. What is the ratio of the Education completion rate(%) in Jamaica in 2001 to that in 2003?
Your answer should be very brief. 1.02. What is the ratio of the Education completion rate(%) of Senegal in 2001 to that in 2003?
Ensure brevity in your answer.  0.7. What is the ratio of the Education completion rate(%) of Heavily indebted poor countries in 2001 to that in 2004?
Your response must be concise. 0.88. What is the ratio of the Education completion rate(%) in Belarus in 2001 to that in 2004?
Offer a terse response. 0.91. What is the ratio of the Education completion rate(%) in Jamaica in 2001 to that in 2004?
Your response must be concise. 0.95. What is the ratio of the Education completion rate(%) in Senegal in 2001 to that in 2004?
Make the answer very short. 0.77. What is the ratio of the Education completion rate(%) of Heavily indebted poor countries in 2001 to that in 2005?
Your answer should be very brief. 0.84. What is the ratio of the Education completion rate(%) of Belarus in 2001 to that in 2005?
Your answer should be very brief. 0.87. What is the ratio of the Education completion rate(%) in Jamaica in 2001 to that in 2005?
Offer a terse response. 0.96. What is the ratio of the Education completion rate(%) in Senegal in 2001 to that in 2005?
Ensure brevity in your answer.  0.71. What is the ratio of the Education completion rate(%) in Heavily indebted poor countries in 2001 to that in 2009?
Your answer should be compact. 0.68. What is the ratio of the Education completion rate(%) in Belarus in 2001 to that in 2009?
Provide a short and direct response. 0.47. What is the ratio of the Education completion rate(%) of Jamaica in 2001 to that in 2009?
Your answer should be very brief. 0.96. What is the ratio of the Education completion rate(%) of Senegal in 2001 to that in 2009?
Make the answer very short. 0.53. What is the ratio of the Education completion rate(%) in Heavily indebted poor countries in 2002 to that in 2003?
Offer a very short reply. 0.97. What is the ratio of the Education completion rate(%) in Jamaica in 2002 to that in 2003?
Ensure brevity in your answer.  0.98. What is the ratio of the Education completion rate(%) in Senegal in 2002 to that in 2003?
Give a very brief answer. 0.75. What is the ratio of the Education completion rate(%) of Heavily indebted poor countries in 2002 to that in 2004?
Provide a short and direct response. 0.93. What is the ratio of the Education completion rate(%) in Belarus in 2002 to that in 2004?
Provide a short and direct response. 0.91. What is the ratio of the Education completion rate(%) of Jamaica in 2002 to that in 2004?
Give a very brief answer. 0.91. What is the ratio of the Education completion rate(%) of Senegal in 2002 to that in 2004?
Offer a very short reply. 0.82. What is the ratio of the Education completion rate(%) in Heavily indebted poor countries in 2002 to that in 2005?
Provide a short and direct response. 0.89. What is the ratio of the Education completion rate(%) of Belarus in 2002 to that in 2005?
Provide a succinct answer. 0.87. What is the ratio of the Education completion rate(%) in Jamaica in 2002 to that in 2005?
Your answer should be very brief. 0.92. What is the ratio of the Education completion rate(%) in Senegal in 2002 to that in 2005?
Your response must be concise. 0.76. What is the ratio of the Education completion rate(%) of Heavily indebted poor countries in 2002 to that in 2009?
Offer a very short reply. 0.72. What is the ratio of the Education completion rate(%) in Belarus in 2002 to that in 2009?
Provide a succinct answer. 0.47. What is the ratio of the Education completion rate(%) of Jamaica in 2002 to that in 2009?
Offer a terse response. 0.92. What is the ratio of the Education completion rate(%) in Senegal in 2002 to that in 2009?
Offer a terse response. 0.56. What is the ratio of the Education completion rate(%) of Heavily indebted poor countries in 2003 to that in 2004?
Offer a terse response. 0.96. What is the ratio of the Education completion rate(%) in Belarus in 2003 to that in 2004?
Give a very brief answer. 0.94. What is the ratio of the Education completion rate(%) in Jamaica in 2003 to that in 2004?
Your response must be concise. 0.93. What is the ratio of the Education completion rate(%) of Senegal in 2003 to that in 2004?
Ensure brevity in your answer.  1.09. What is the ratio of the Education completion rate(%) in Heavily indebted poor countries in 2003 to that in 2005?
Give a very brief answer. 0.92. What is the ratio of the Education completion rate(%) in Belarus in 2003 to that in 2005?
Give a very brief answer. 0.9. What is the ratio of the Education completion rate(%) of Jamaica in 2003 to that in 2005?
Your response must be concise. 0.94. What is the ratio of the Education completion rate(%) of Senegal in 2003 to that in 2005?
Offer a terse response. 1.01. What is the ratio of the Education completion rate(%) in Heavily indebted poor countries in 2003 to that in 2009?
Your answer should be very brief. 0.75. What is the ratio of the Education completion rate(%) of Belarus in 2003 to that in 2009?
Offer a very short reply. 0.48. What is the ratio of the Education completion rate(%) in Jamaica in 2003 to that in 2009?
Give a very brief answer. 0.94. What is the ratio of the Education completion rate(%) of Senegal in 2003 to that in 2009?
Provide a succinct answer. 0.75. What is the ratio of the Education completion rate(%) in Heavily indebted poor countries in 2004 to that in 2005?
Keep it short and to the point. 0.96. What is the ratio of the Education completion rate(%) of Belarus in 2004 to that in 2005?
Ensure brevity in your answer.  0.96. What is the ratio of the Education completion rate(%) of Senegal in 2004 to that in 2005?
Your answer should be very brief. 0.92. What is the ratio of the Education completion rate(%) in Heavily indebted poor countries in 2004 to that in 2009?
Offer a very short reply. 0.78. What is the ratio of the Education completion rate(%) in Belarus in 2004 to that in 2009?
Provide a succinct answer. 0.51. What is the ratio of the Education completion rate(%) of Jamaica in 2004 to that in 2009?
Give a very brief answer. 1.01. What is the ratio of the Education completion rate(%) in Senegal in 2004 to that in 2009?
Offer a very short reply. 0.68. What is the ratio of the Education completion rate(%) of Heavily indebted poor countries in 2005 to that in 2009?
Keep it short and to the point. 0.81. What is the ratio of the Education completion rate(%) of Belarus in 2005 to that in 2009?
Offer a terse response. 0.53. What is the ratio of the Education completion rate(%) of Jamaica in 2005 to that in 2009?
Offer a very short reply. 1. What is the ratio of the Education completion rate(%) of Senegal in 2005 to that in 2009?
Keep it short and to the point. 0.74. What is the difference between the highest and the second highest Education completion rate(%) in Heavily indebted poor countries?
Offer a terse response. 6.93. What is the difference between the highest and the second highest Education completion rate(%) in Belarus?
Keep it short and to the point. 96.27. What is the difference between the highest and the second highest Education completion rate(%) in Jamaica?
Make the answer very short. 0.79. What is the difference between the highest and the second highest Education completion rate(%) in Senegal?
Ensure brevity in your answer.  7.78. What is the difference between the highest and the lowest Education completion rate(%) of Heavily indebted poor countries?
Make the answer very short. 12.62. What is the difference between the highest and the lowest Education completion rate(%) in Belarus?
Provide a short and direct response. 113.22. What is the difference between the highest and the lowest Education completion rate(%) of Jamaica?
Your answer should be compact. 9.01. What is the difference between the highest and the lowest Education completion rate(%) of Senegal?
Ensure brevity in your answer.  14.54. 